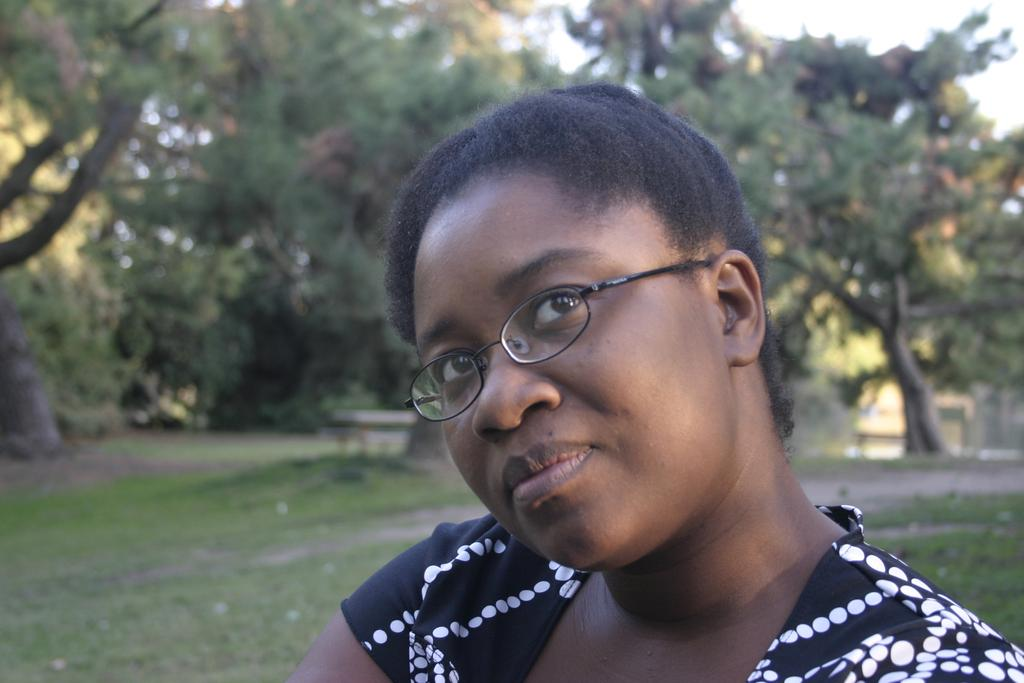Who is the main subject in the image? There is a lady in the image. What is the lady wearing on her face? The lady is wearing specs. What type of vegetation can be seen in the background of the image? There are trees in the background of the image. What is the ground made of in the image? The ground is covered with grass in the image. How would you describe the background of the image? The background is blurry. What type of nest can be seen in the image? There is no nest present in the image. What language is the lady speaking in the image? The image does not provide any information about the language being spoken. 